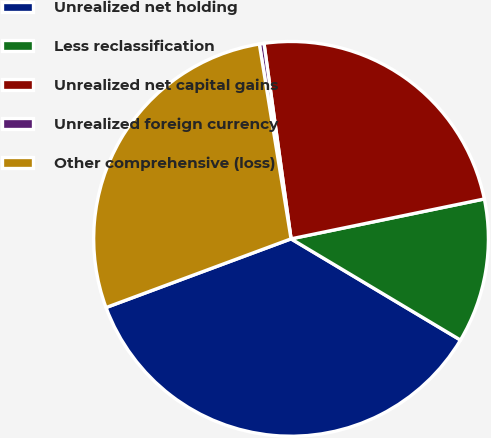<chart> <loc_0><loc_0><loc_500><loc_500><pie_chart><fcel>Unrealized net holding<fcel>Less reclassification<fcel>Unrealized net capital gains<fcel>Unrealized foreign currency<fcel>Other comprehensive (loss)<nl><fcel>35.77%<fcel>11.81%<fcel>23.95%<fcel>0.38%<fcel>28.09%<nl></chart> 